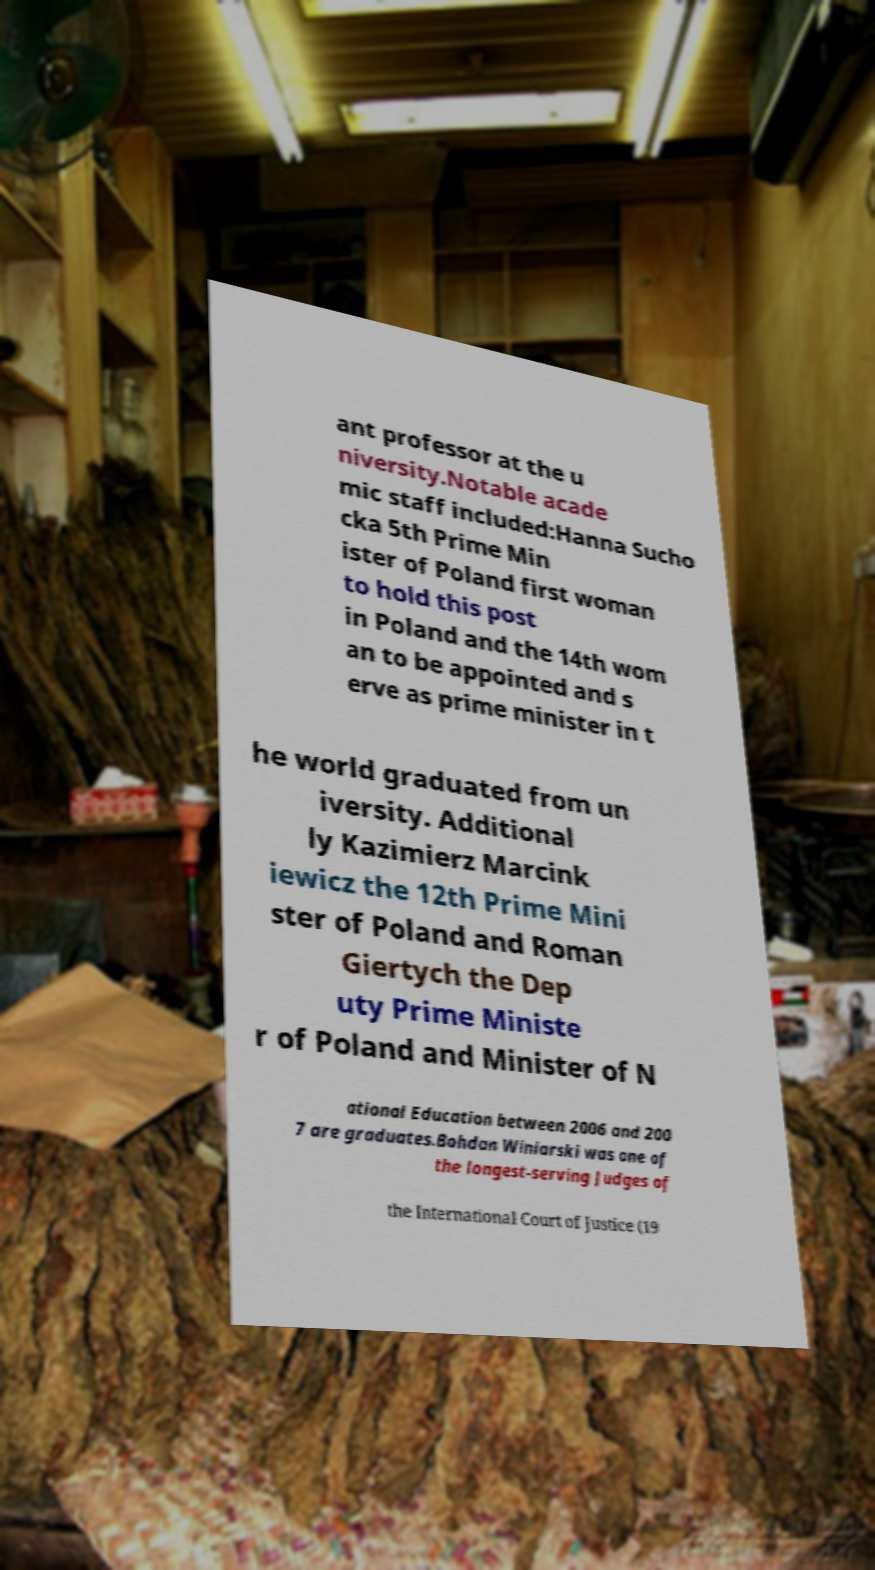I need the written content from this picture converted into text. Can you do that? ant professor at the u niversity.Notable acade mic staff included:Hanna Sucho cka 5th Prime Min ister of Poland first woman to hold this post in Poland and the 14th wom an to be appointed and s erve as prime minister in t he world graduated from un iversity. Additional ly Kazimierz Marcink iewicz the 12th Prime Mini ster of Poland and Roman Giertych the Dep uty Prime Ministe r of Poland and Minister of N ational Education between 2006 and 200 7 are graduates.Bohdan Winiarski was one of the longest-serving Judges of the International Court of Justice (19 